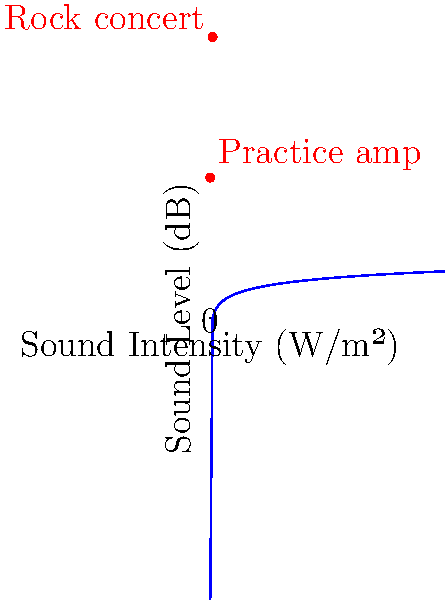Using the logarithmic scale shown in the graph, estimate the difference in decibel level between a typical rock concert and your practice amplifier. How many times louder is the rock concert compared to your practice sessions? To solve this problem, let's follow these steps:

1) From the graph, we can see that:
   - The practice amp is at approximately 60 dB
   - The rock concert is at approximately 120 dB

2) The difference in decibel level is:
   $120 \text{ dB} - 60 \text{ dB} = 60 \text{ dB}$

3) Remember that the decibel scale is logarithmic. Every 10 dB increase represents a 10-fold increase in sound intensity.

4) A 60 dB increase represents $6$ increases of 10 dB each.

5) This means the intensity has increased by a factor of $10^6 = 1,000,000$

Therefore, the rock concert is 1,000,000 times louder than your practice sessions.

This demonstrates why hearing protection is crucial, especially at loud concerts. Your mentor's guidance on mindful hearing protection is very important for preserving your long-term hearing health as a guitarist.
Answer: 60 dB difference; 1,000,000 times louder 